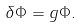<formula> <loc_0><loc_0><loc_500><loc_500>\delta \Phi = g \Phi .</formula> 